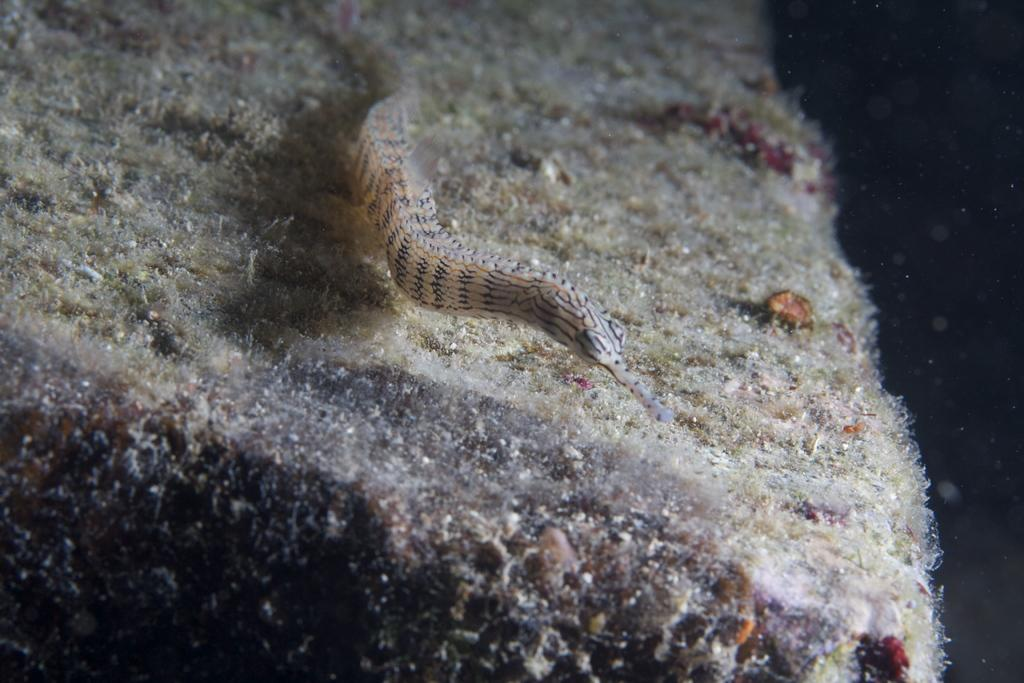What type of creature can be seen in the image? There is an insect in the image. Where is the insect located in the image? The insect is on a surface. What type of attraction is the insect visiting in the image? There is no attraction present in the image; it only features an insect on a surface. 